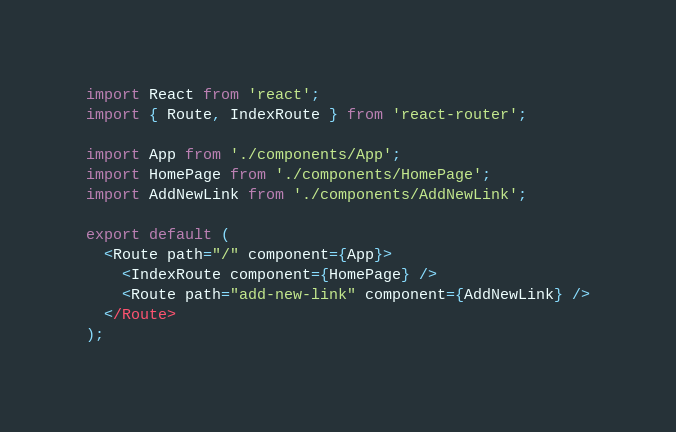Convert code to text. <code><loc_0><loc_0><loc_500><loc_500><_JavaScript_>import React from 'react';
import { Route, IndexRoute } from 'react-router';

import App from './components/App';
import HomePage from './components/HomePage';
import AddNewLink from './components/AddNewLink';

export default (
  <Route path="/" component={App}>
    <IndexRoute component={HomePage} />
    <Route path="add-new-link" component={AddNewLink} />
  </Route>
);
</code> 